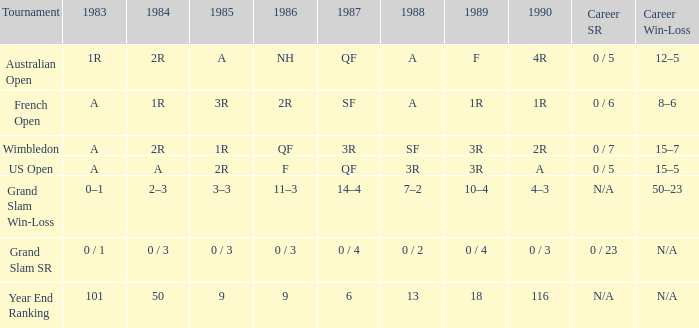With a 1986 of nh and a professional sr of 0 / 5, what are the outcomes in 1985? A. 